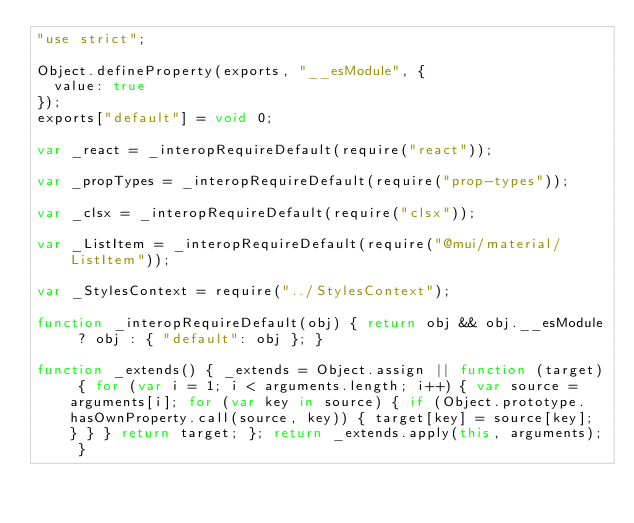Convert code to text. <code><loc_0><loc_0><loc_500><loc_500><_JavaScript_>"use strict";

Object.defineProperty(exports, "__esModule", {
  value: true
});
exports["default"] = void 0;

var _react = _interopRequireDefault(require("react"));

var _propTypes = _interopRequireDefault(require("prop-types"));

var _clsx = _interopRequireDefault(require("clsx"));

var _ListItem = _interopRequireDefault(require("@mui/material/ListItem"));

var _StylesContext = require("../StylesContext");

function _interopRequireDefault(obj) { return obj && obj.__esModule ? obj : { "default": obj }; }

function _extends() { _extends = Object.assign || function (target) { for (var i = 1; i < arguments.length; i++) { var source = arguments[i]; for (var key in source) { if (Object.prototype.hasOwnProperty.call(source, key)) { target[key] = source[key]; } } } return target; }; return _extends.apply(this, arguments); }
</code> 